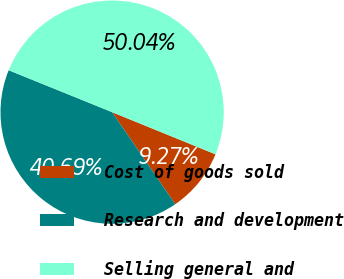<chart> <loc_0><loc_0><loc_500><loc_500><pie_chart><fcel>Cost of goods sold<fcel>Research and development<fcel>Selling general and<nl><fcel>9.27%<fcel>40.69%<fcel>50.03%<nl></chart> 